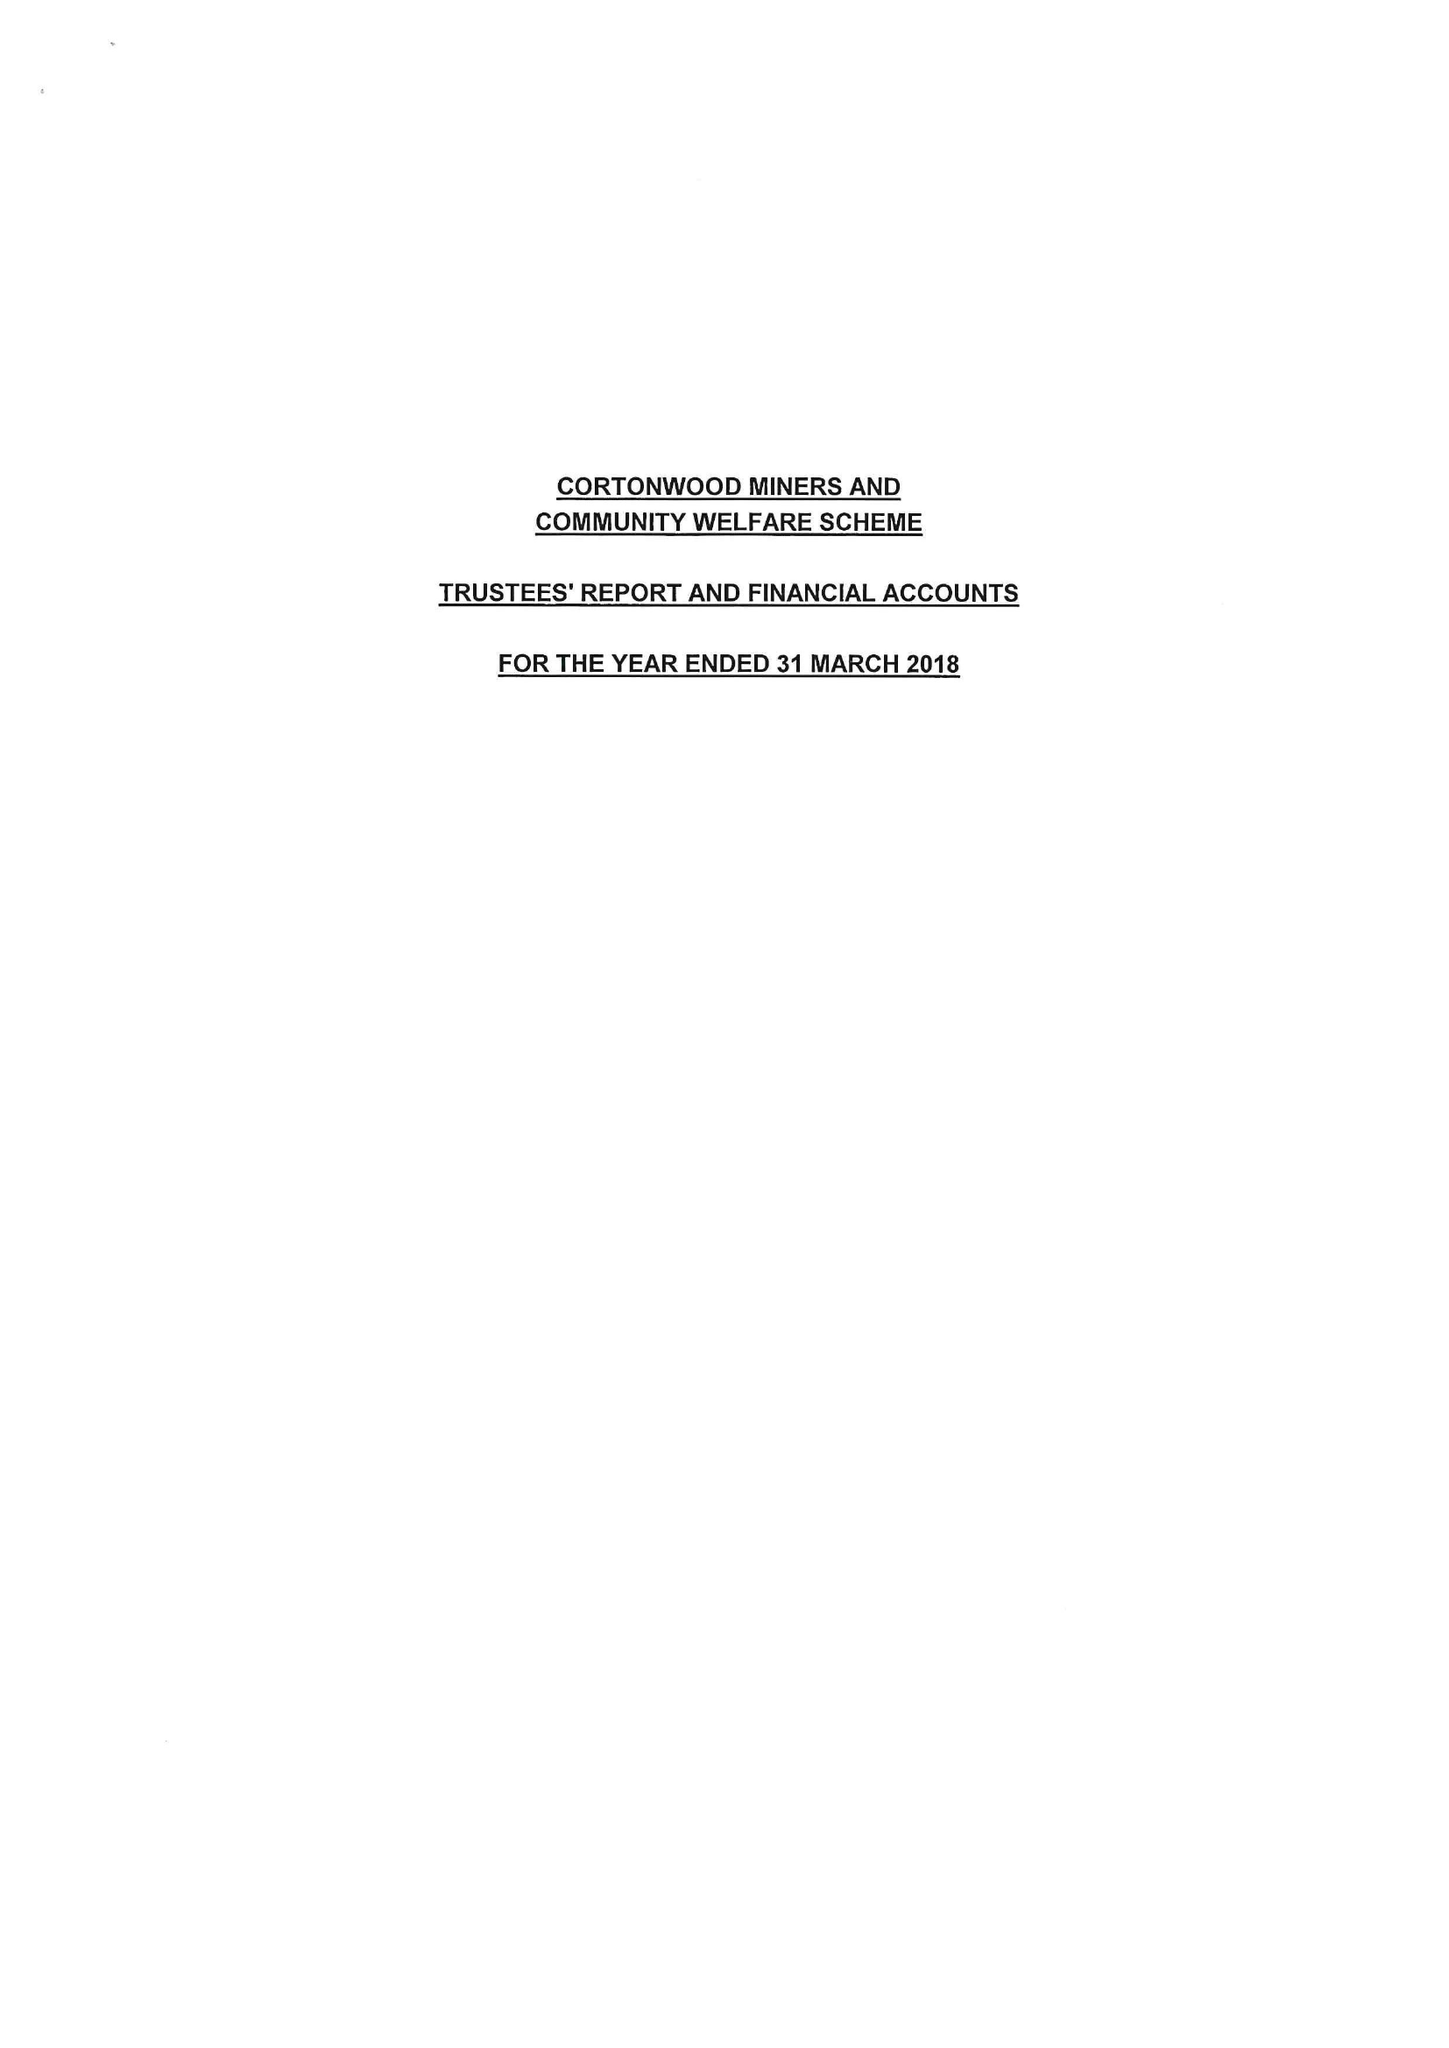What is the value for the report_date?
Answer the question using a single word or phrase. 2018-03-31 